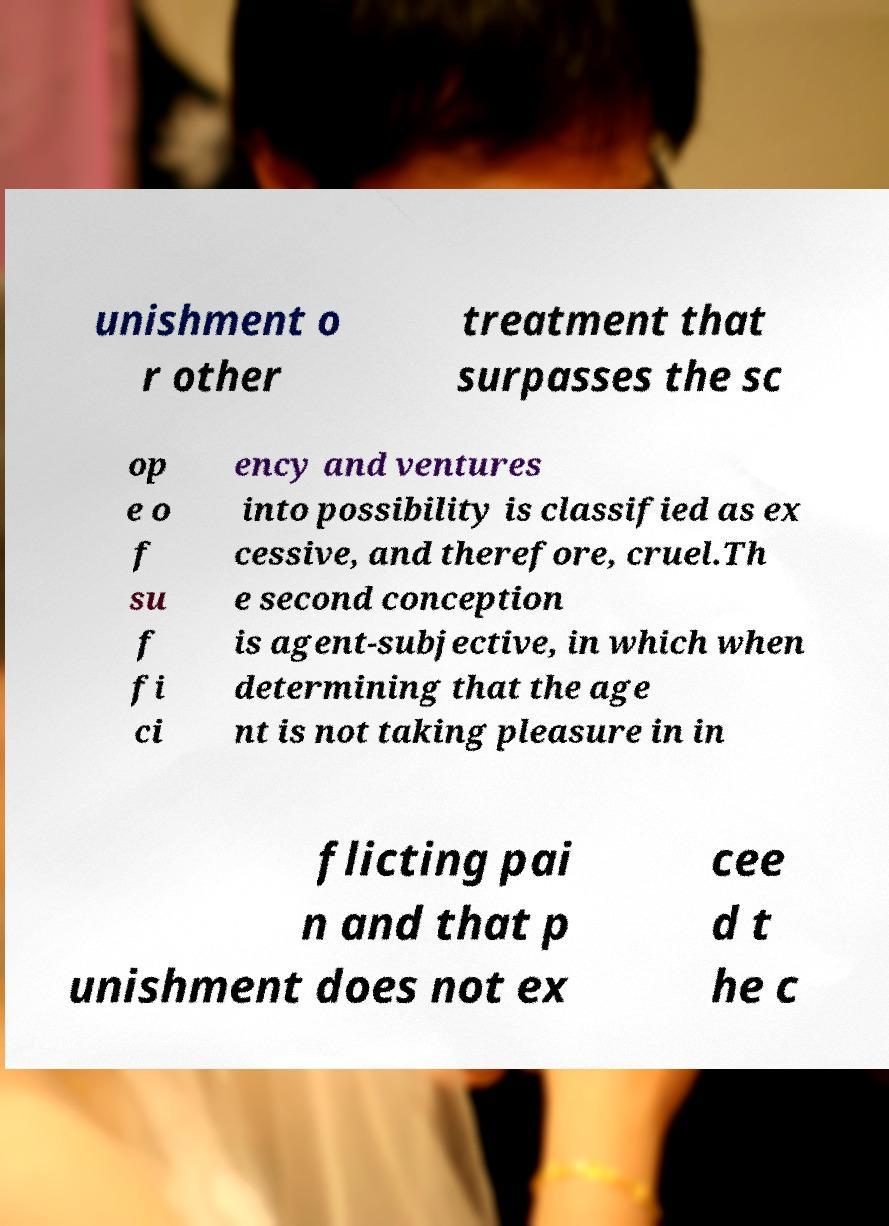Could you extract and type out the text from this image? unishment o r other treatment that surpasses the sc op e o f su f fi ci ency and ventures into possibility is classified as ex cessive, and therefore, cruel.Th e second conception is agent-subjective, in which when determining that the age nt is not taking pleasure in in flicting pai n and that p unishment does not ex cee d t he c 